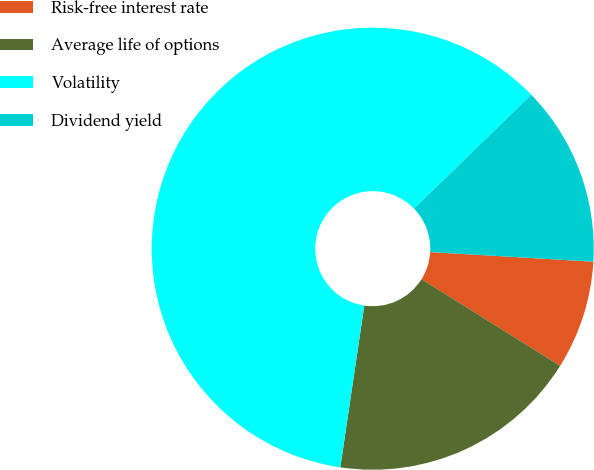<chart> <loc_0><loc_0><loc_500><loc_500><pie_chart><fcel>Risk-free interest rate<fcel>Average life of options<fcel>Volatility<fcel>Dividend yield<nl><fcel>7.96%<fcel>18.45%<fcel>60.39%<fcel>13.2%<nl></chart> 